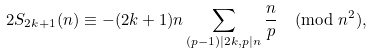Convert formula to latex. <formula><loc_0><loc_0><loc_500><loc_500>2 S _ { 2 k + 1 } ( n ) \equiv - ( 2 k + 1 ) n \sum _ { ( p - 1 ) | 2 k , p | n } \frac { n } { p } \pmod { n ^ { 2 } } ,</formula> 